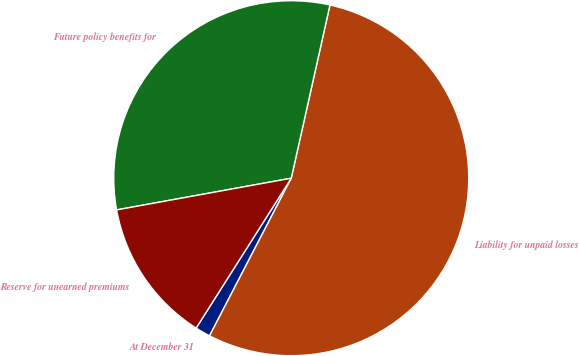Convert chart. <chart><loc_0><loc_0><loc_500><loc_500><pie_chart><fcel>At December 31<fcel>Liability for unpaid losses<fcel>Future policy benefits for<fcel>Reserve for unearned premiums<nl><fcel>1.39%<fcel>54.11%<fcel>31.36%<fcel>13.14%<nl></chart> 